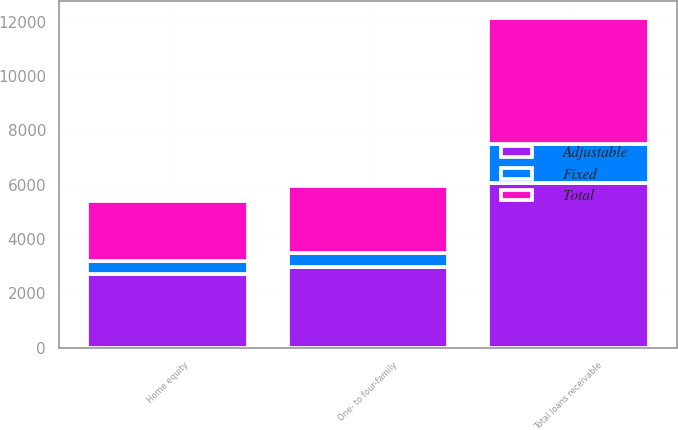Convert chart. <chart><loc_0><loc_0><loc_500><loc_500><stacked_bar_chart><ecel><fcel>One- to four-family<fcel>Home equity<fcel>Total loans receivable<nl><fcel>Fixed<fcel>506<fcel>498<fcel>1412<nl><fcel>Total<fcel>2460<fcel>2193<fcel>4653<nl><fcel>Adjustable<fcel>2966<fcel>2691<fcel>6065<nl></chart> 